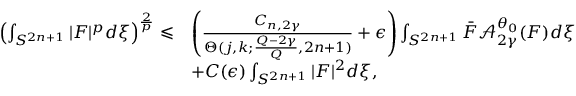<formula> <loc_0><loc_0><loc_500><loc_500>\begin{array} { r l } { \left ( \int _ { S ^ { 2 n + 1 } } | F | ^ { p } d \xi \right ) ^ { \frac { 2 } { p } } \leqslant } & { \left ( \frac { { C } _ { n , 2 \gamma } } { \Theta ( { j , k } ; \frac { Q - 2 \gamma } { Q } , 2 n + 1 ) } + \epsilon \right ) \int _ { S ^ { 2 n + 1 } } \bar { F } \mathcal { A } _ { 2 \gamma } ^ { \theta _ { 0 } } ( F ) d \xi } \\ & { + C ( \epsilon ) \int _ { S ^ { 2 n + 1 } } | F | ^ { 2 } d \xi , } \end{array}</formula> 